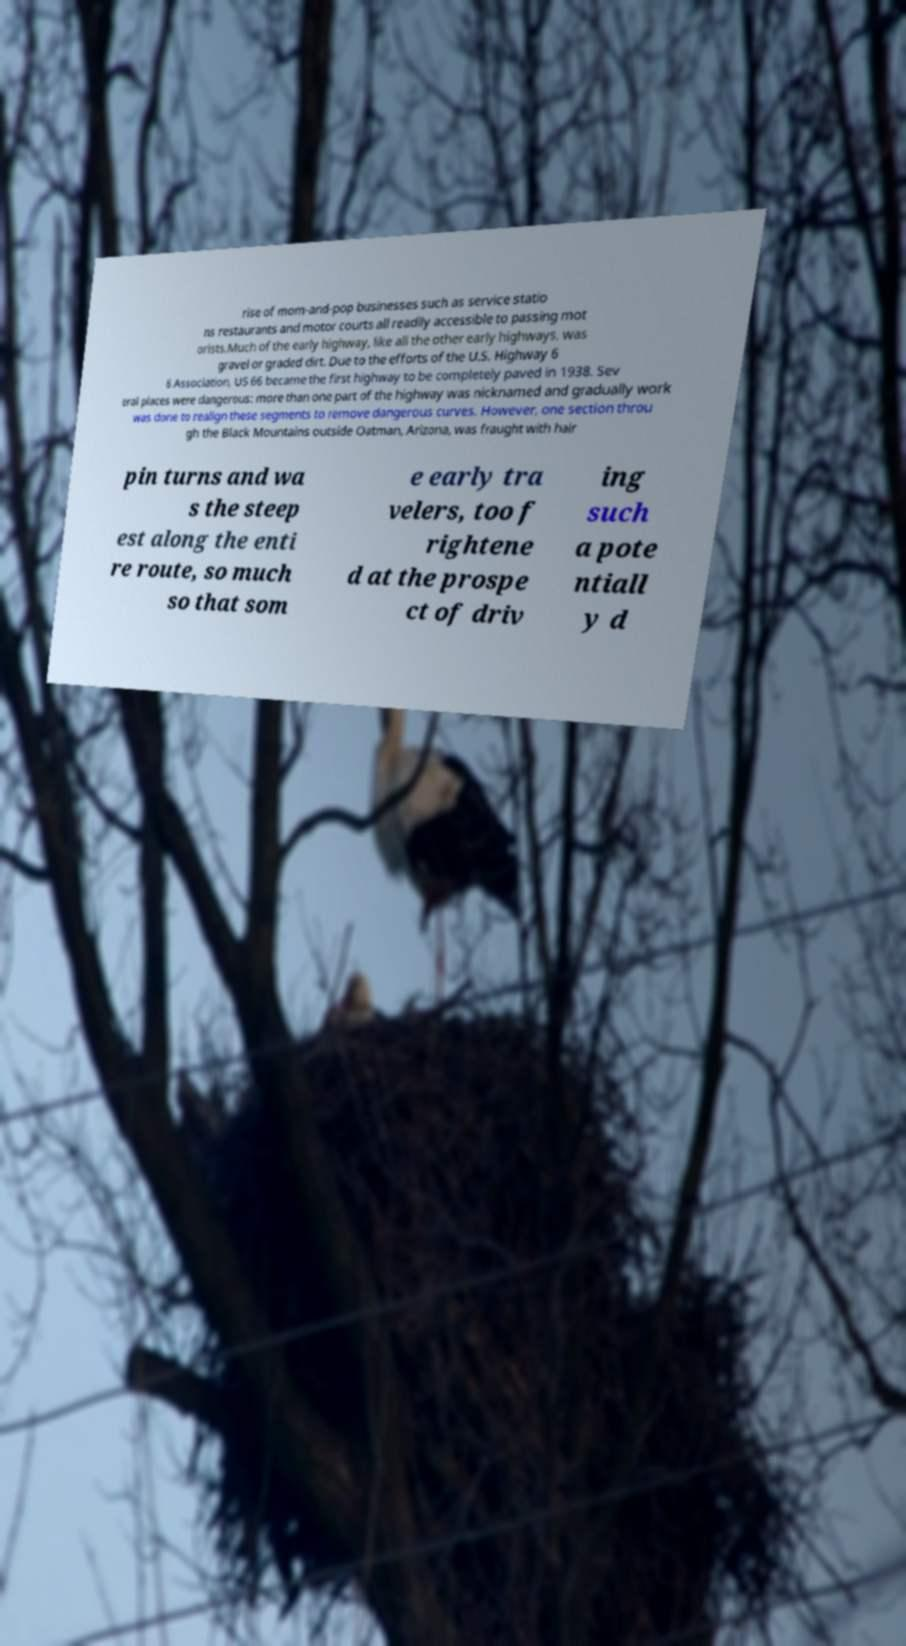Please read and relay the text visible in this image. What does it say? rise of mom-and-pop businesses such as service statio ns restaurants and motor courts all readily accessible to passing mot orists.Much of the early highway, like all the other early highways, was gravel or graded dirt. Due to the efforts of the U.S. Highway 6 6 Association, US 66 became the first highway to be completely paved in 1938. Sev eral places were dangerous: more than one part of the highway was nicknamed and gradually work was done to realign these segments to remove dangerous curves. However, one section throu gh the Black Mountains outside Oatman, Arizona, was fraught with hair pin turns and wa s the steep est along the enti re route, so much so that som e early tra velers, too f rightene d at the prospe ct of driv ing such a pote ntiall y d 